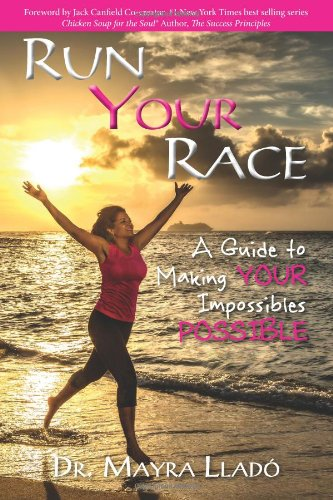What themes are primarily discussed in this book? 'Run Your Race' covers themes such as overcoming adversity, personal resilience, goal setting, and the importance of persistence and determination in achieving one's personal goals. 